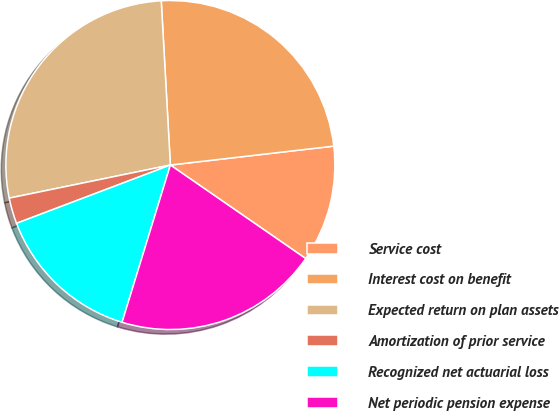<chart> <loc_0><loc_0><loc_500><loc_500><pie_chart><fcel>Service cost<fcel>Interest cost on benefit<fcel>Expected return on plan assets<fcel>Amortization of prior service<fcel>Recognized net actuarial loss<fcel>Net periodic pension expense<nl><fcel>11.46%<fcel>24.05%<fcel>27.34%<fcel>2.54%<fcel>14.49%<fcel>20.12%<nl></chart> 